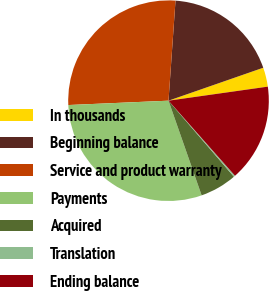Convert chart to OTSL. <chart><loc_0><loc_0><loc_500><loc_500><pie_chart><fcel>In thousands<fcel>Beginning balance<fcel>Service and product warranty<fcel>Payments<fcel>Acquired<fcel>Translation<fcel>Ending balance<nl><fcel>3.09%<fcel>18.56%<fcel>26.8%<fcel>29.66%<fcel>5.95%<fcel>0.23%<fcel>15.7%<nl></chart> 